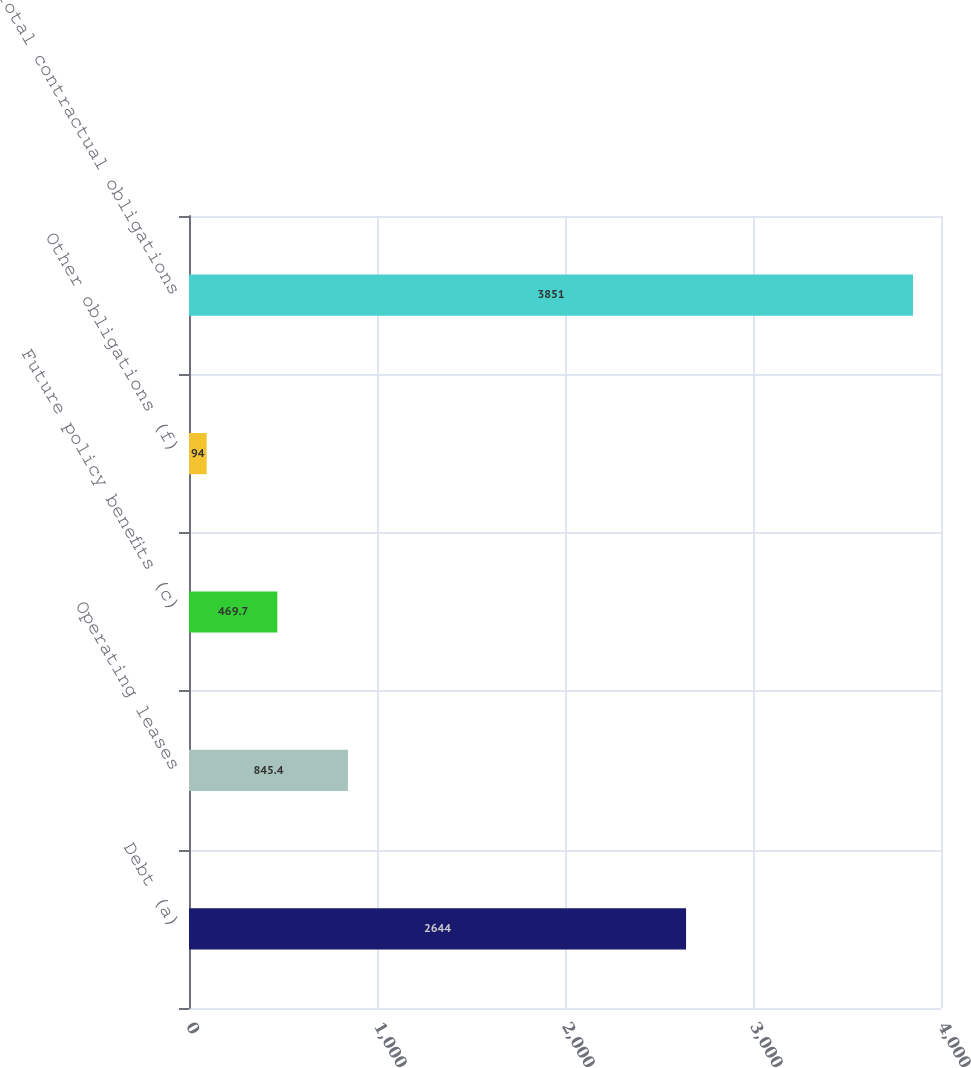Convert chart to OTSL. <chart><loc_0><loc_0><loc_500><loc_500><bar_chart><fcel>Debt (a)<fcel>Operating leases<fcel>Future policy benefits (c)<fcel>Other obligations (f)<fcel>Total contractual obligations<nl><fcel>2644<fcel>845.4<fcel>469.7<fcel>94<fcel>3851<nl></chart> 